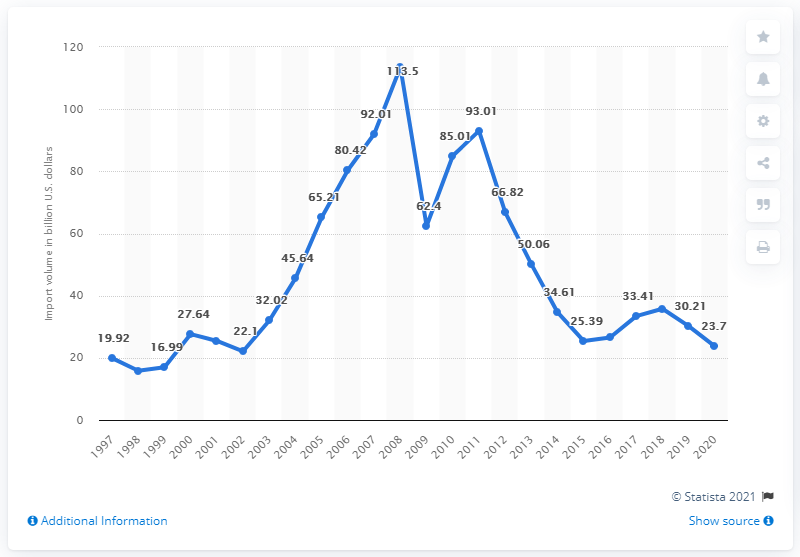Mention a couple of crucial points in this snapshot. In 2020, the United States imported a total of 33.41 billion dollars worth of goods from Africa. 